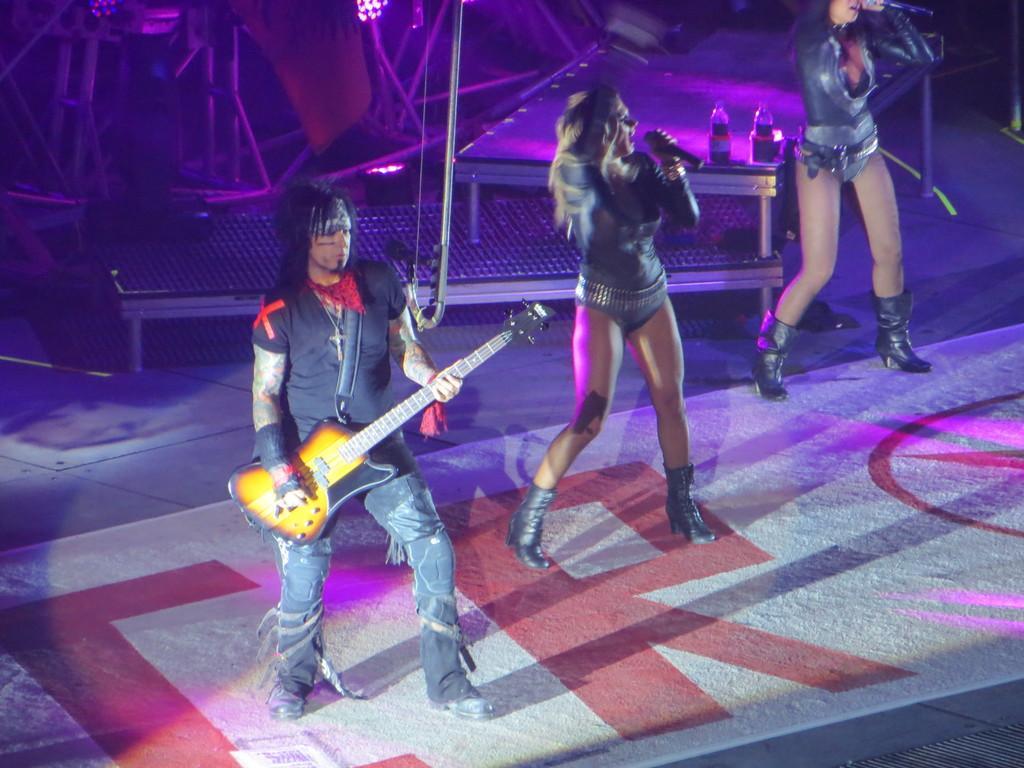Describe this image in one or two sentences. This person is playing guitar. This woman is singing in-front of mic. On this table there are bottles. This woman is also singing in-front of mic. This is focusing light. 